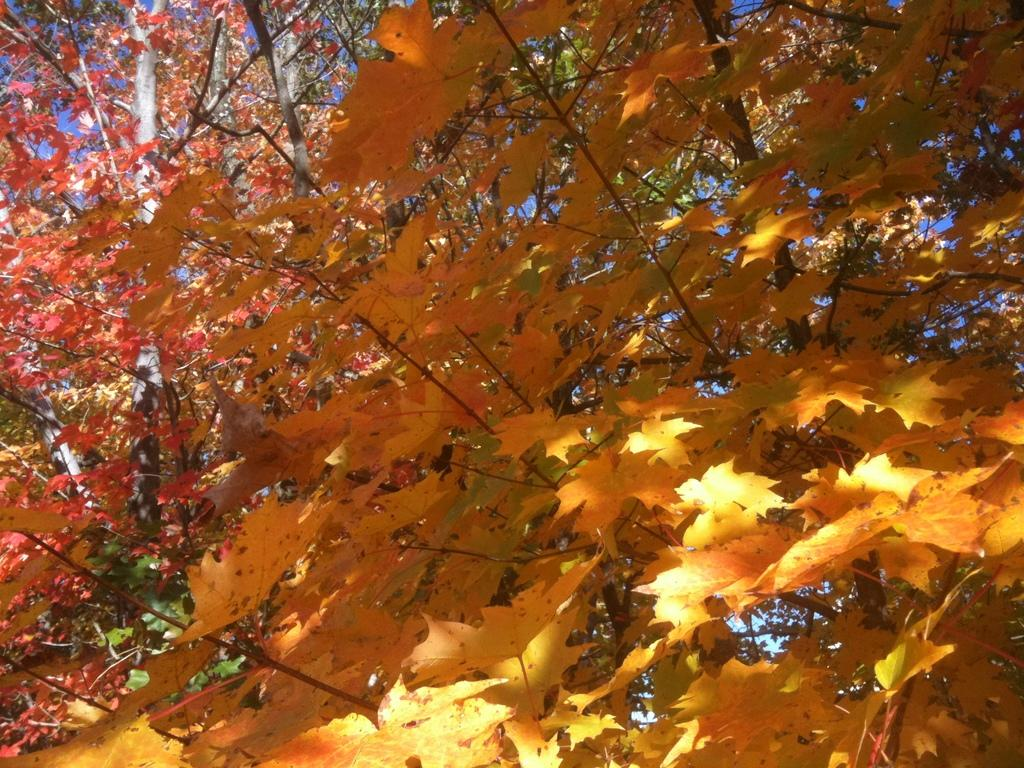What type of natural scenery can be seen in the background of the image? There are trees in the background of the image. What else is visible in the background of the image? The sky is visible in the background of the image. Can you see the actor kissing in the image? There is no actor or kissing depicted in the image; it only features trees and the sky in the background. 